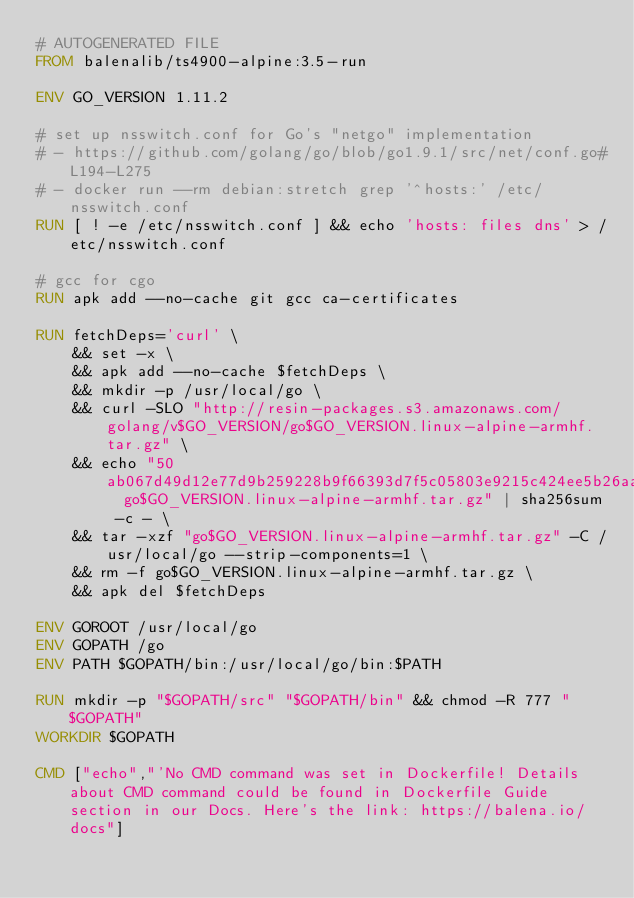<code> <loc_0><loc_0><loc_500><loc_500><_Dockerfile_># AUTOGENERATED FILE
FROM balenalib/ts4900-alpine:3.5-run

ENV GO_VERSION 1.11.2

# set up nsswitch.conf for Go's "netgo" implementation
# - https://github.com/golang/go/blob/go1.9.1/src/net/conf.go#L194-L275
# - docker run --rm debian:stretch grep '^hosts:' /etc/nsswitch.conf
RUN [ ! -e /etc/nsswitch.conf ] && echo 'hosts: files dns' > /etc/nsswitch.conf

# gcc for cgo
RUN apk add --no-cache git gcc ca-certificates

RUN fetchDeps='curl' \
	&& set -x \
	&& apk add --no-cache $fetchDeps \
	&& mkdir -p /usr/local/go \
	&& curl -SLO "http://resin-packages.s3.amazonaws.com/golang/v$GO_VERSION/go$GO_VERSION.linux-alpine-armhf.tar.gz" \
	&& echo "50ab067d49d12e77d9b259228b9f66393d7f5c05803e9215c424ee5b26aadb63  go$GO_VERSION.linux-alpine-armhf.tar.gz" | sha256sum -c - \
	&& tar -xzf "go$GO_VERSION.linux-alpine-armhf.tar.gz" -C /usr/local/go --strip-components=1 \
	&& rm -f go$GO_VERSION.linux-alpine-armhf.tar.gz \
	&& apk del $fetchDeps

ENV GOROOT /usr/local/go
ENV GOPATH /go
ENV PATH $GOPATH/bin:/usr/local/go/bin:$PATH

RUN mkdir -p "$GOPATH/src" "$GOPATH/bin" && chmod -R 777 "$GOPATH"
WORKDIR $GOPATH

CMD ["echo","'No CMD command was set in Dockerfile! Details about CMD command could be found in Dockerfile Guide section in our Docs. Here's the link: https://balena.io/docs"]</code> 